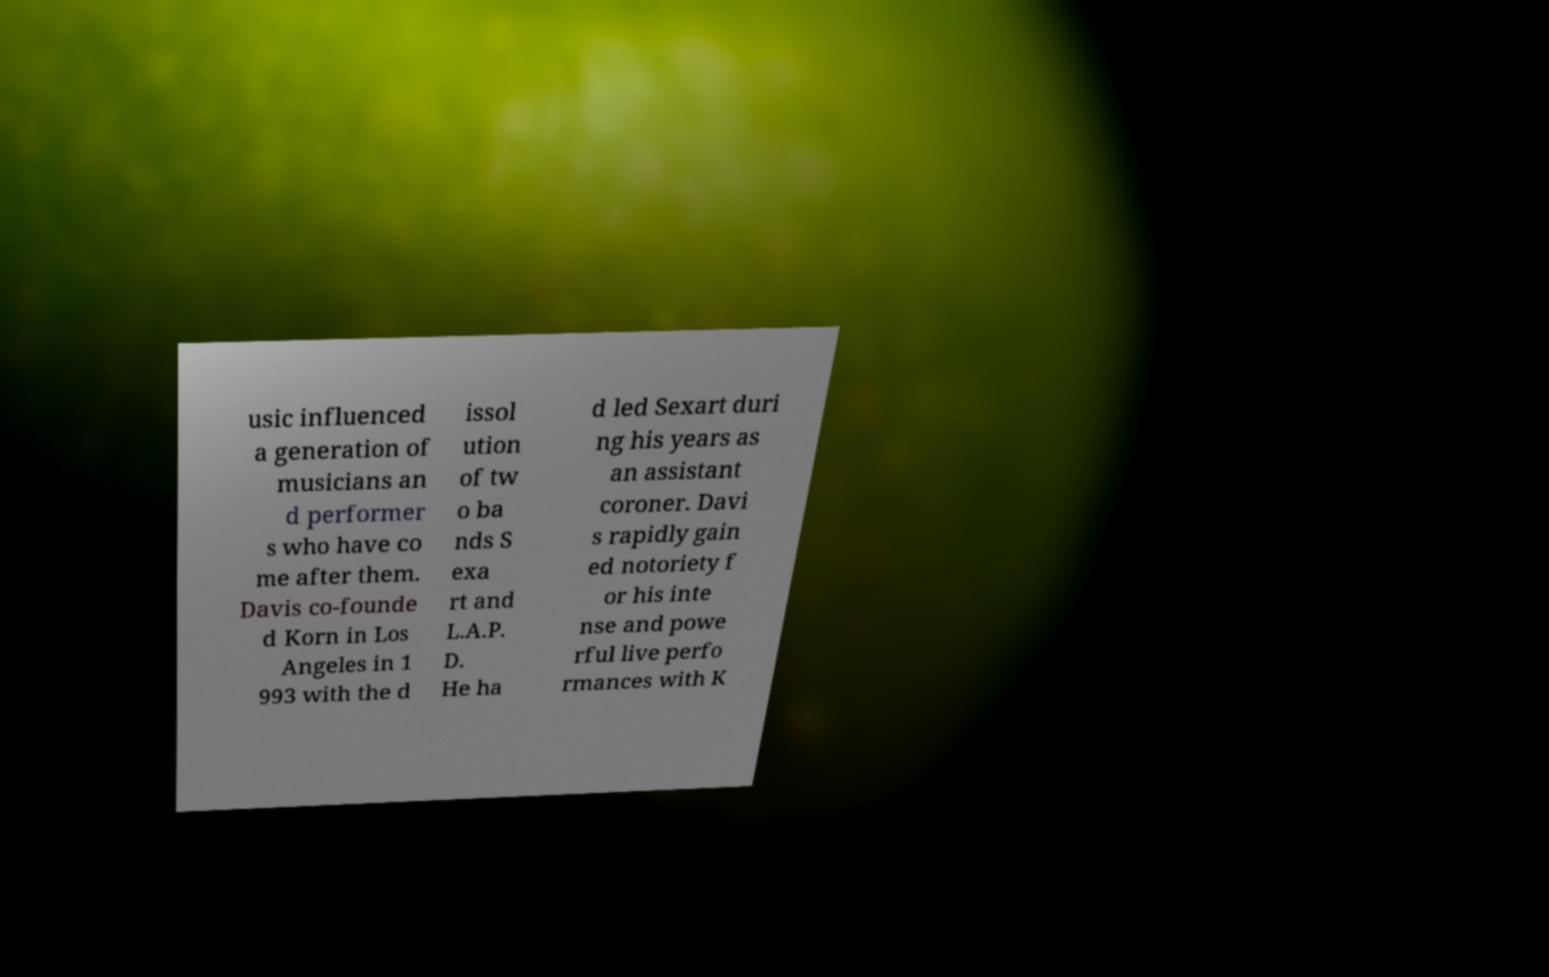Could you assist in decoding the text presented in this image and type it out clearly? usic influenced a generation of musicians an d performer s who have co me after them. Davis co-founde d Korn in Los Angeles in 1 993 with the d issol ution of tw o ba nds S exa rt and L.A.P. D. He ha d led Sexart duri ng his years as an assistant coroner. Davi s rapidly gain ed notoriety f or his inte nse and powe rful live perfo rmances with K 